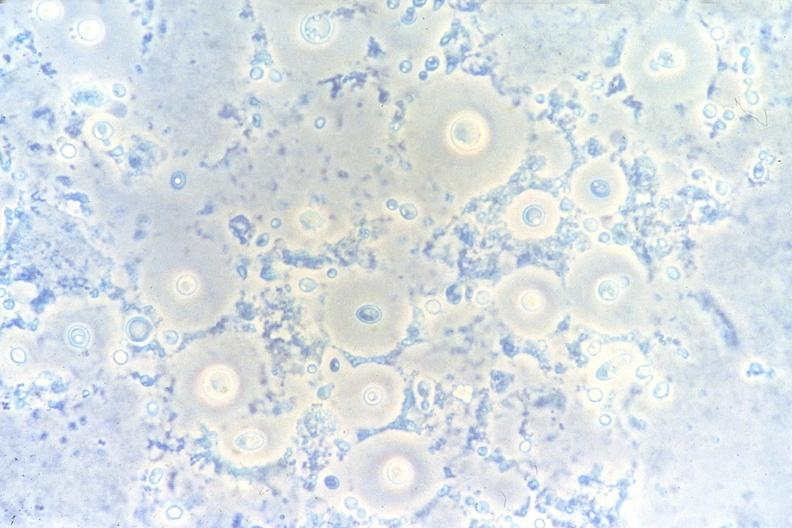s gram present?
Answer the question using a single word or phrase. No 